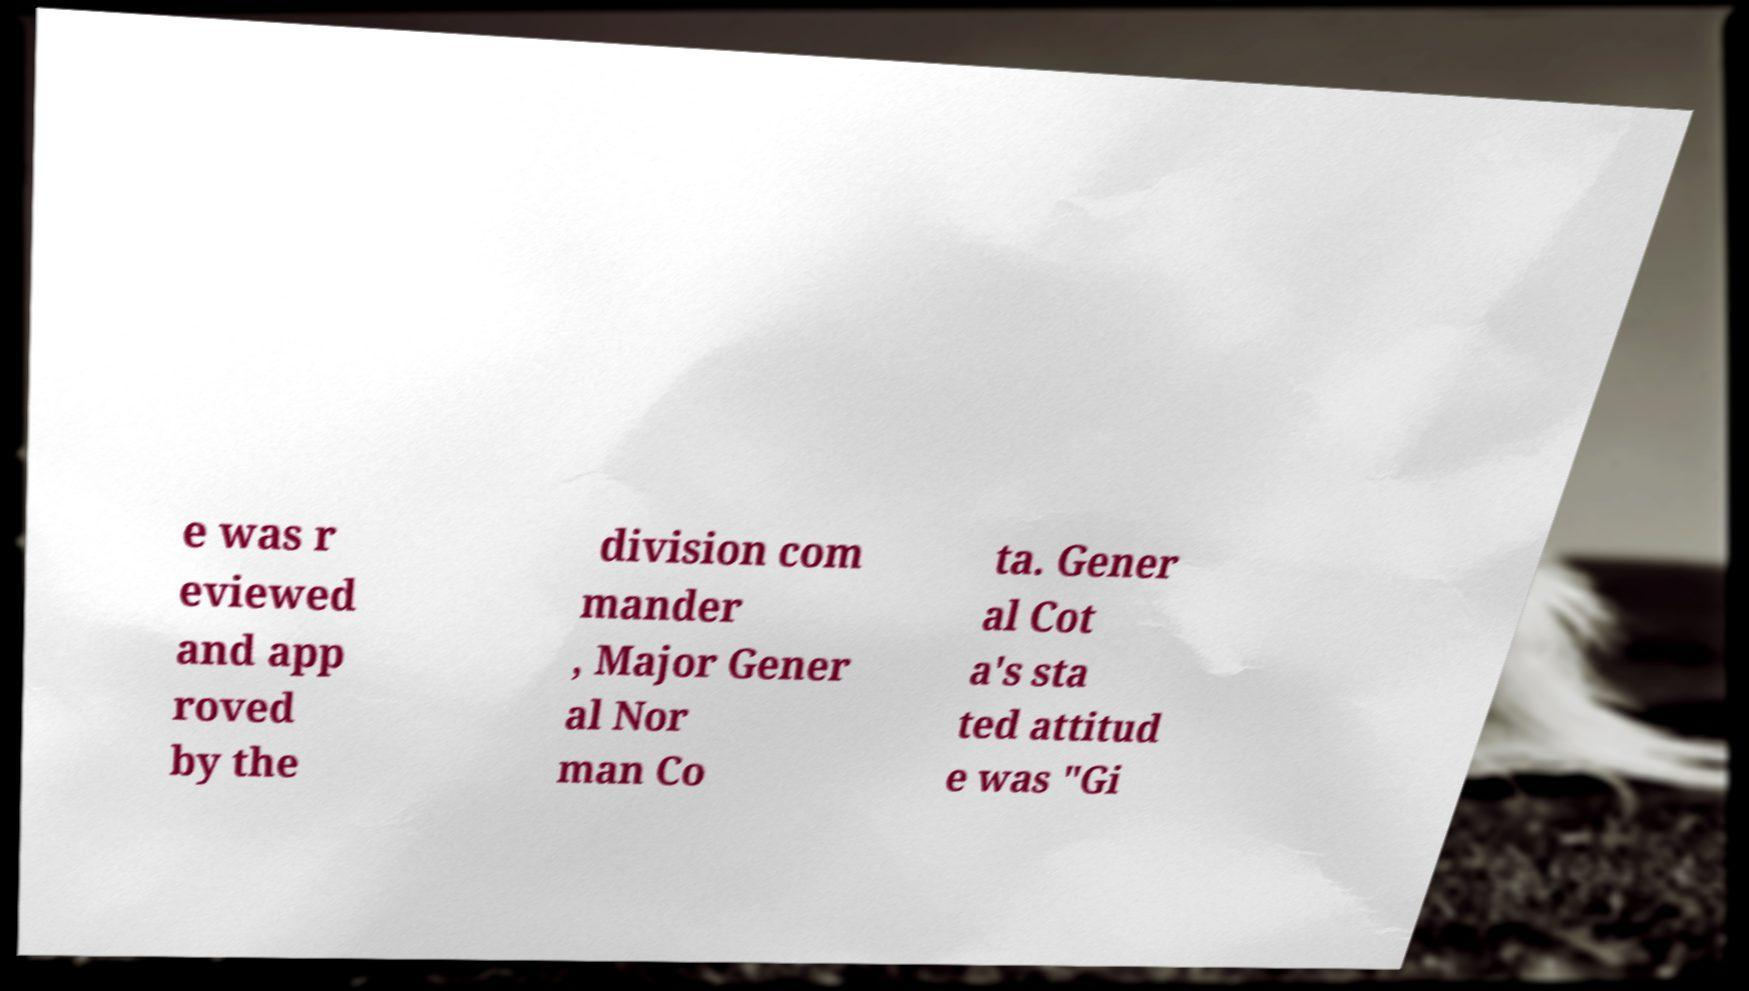For documentation purposes, I need the text within this image transcribed. Could you provide that? e was r eviewed and app roved by the division com mander , Major Gener al Nor man Co ta. Gener al Cot a's sta ted attitud e was "Gi 